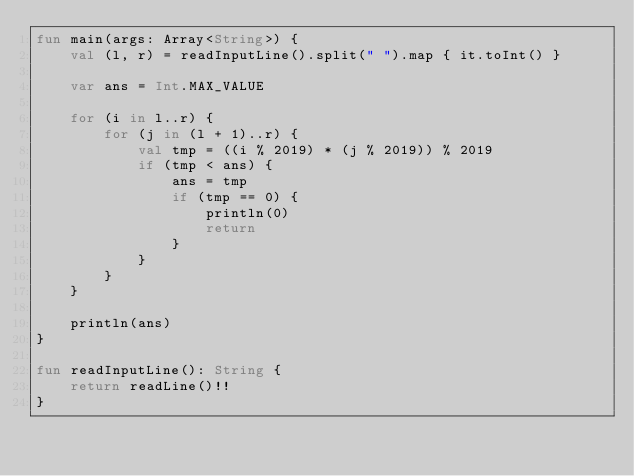Convert code to text. <code><loc_0><loc_0><loc_500><loc_500><_Kotlin_>fun main(args: Array<String>) {
    val (l, r) = readInputLine().split(" ").map { it.toInt() }

    var ans = Int.MAX_VALUE

    for (i in l..r) {
        for (j in (l + 1)..r) {
            val tmp = ((i % 2019) * (j % 2019)) % 2019
            if (tmp < ans) {
                ans = tmp
                if (tmp == 0) {
                    println(0)
                    return
                }
            }
        }
    }
    
    println(ans)
}
 
fun readInputLine(): String {
    return readLine()!!
}
</code> 